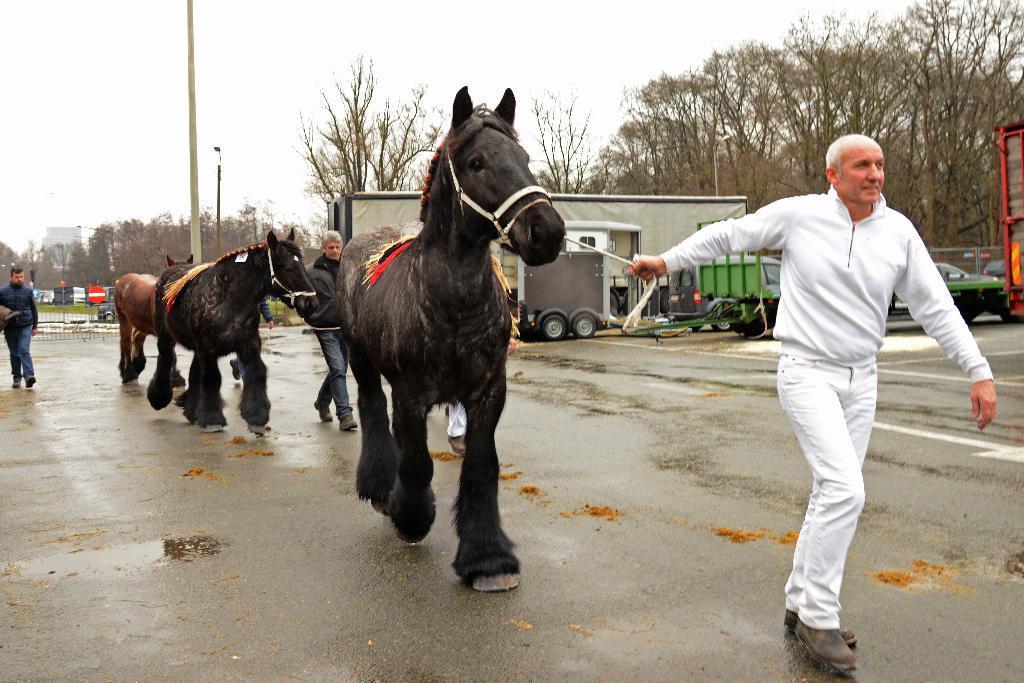Please provide a concise description of this image. In this image we can see three horses walking on the road, beside a person is holding it, at the back there are cars, trucks, on the road, there are trees, there is a fencing, there is a pole, there is a sky. 